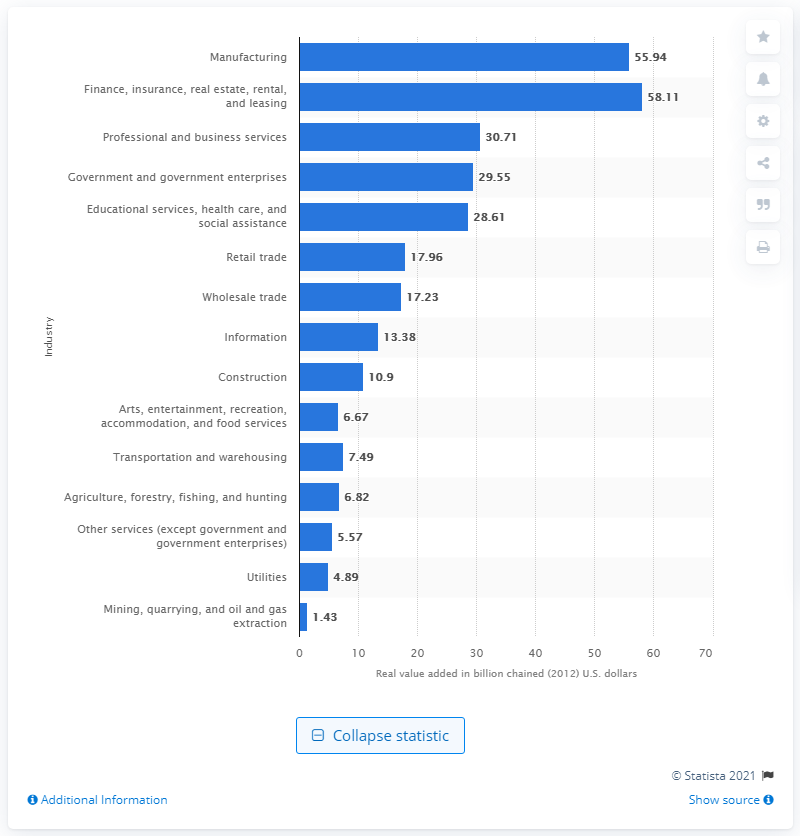Specify some key components in this picture. In 2012, the manufacturing industry contributed $55.94 billion to the state's GDP. 